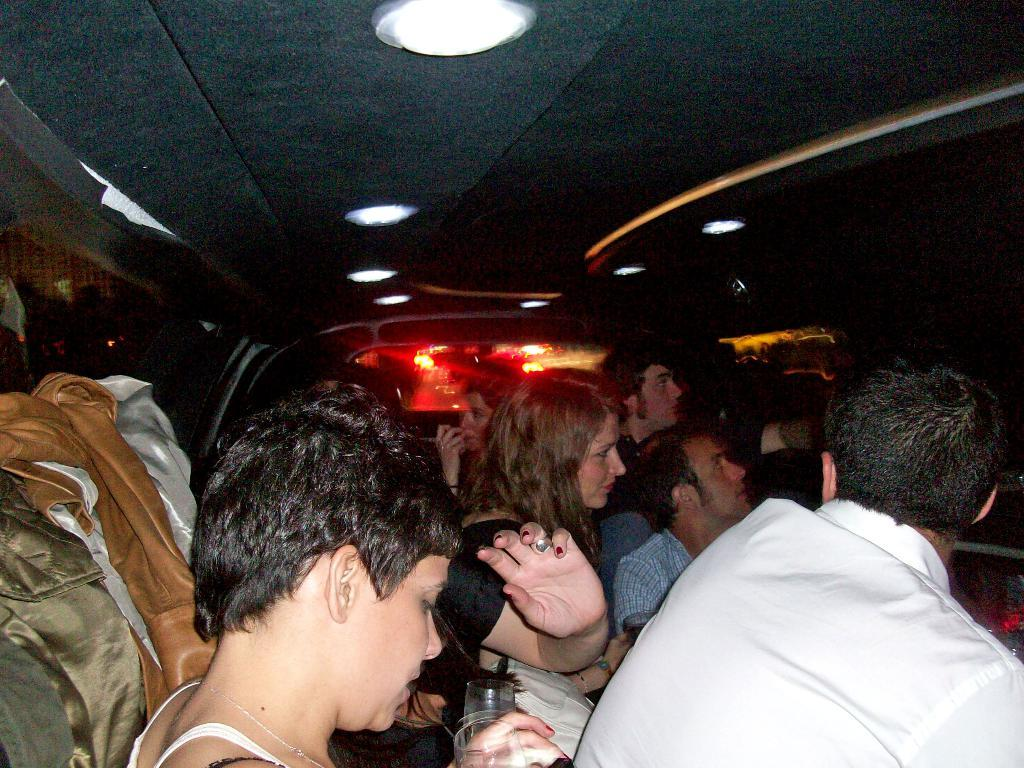Who or what can be seen in the image? There are people in the image. Where are the people located? The people are sitting inside a car. Can you describe the position of the car in the image? The car is in the center of the image. How many beds can be seen in the image? There are no beds present in the image. What type of drop can be observed happening in the image? There is no drop or falling object visible in the image. 